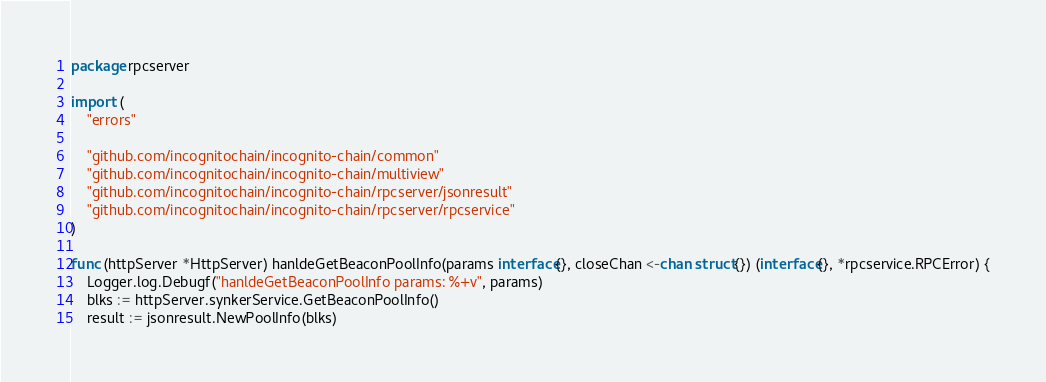<code> <loc_0><loc_0><loc_500><loc_500><_Go_>package rpcserver

import (
	"errors"

	"github.com/incognitochain/incognito-chain/common"
	"github.com/incognitochain/incognito-chain/multiview"
	"github.com/incognitochain/incognito-chain/rpcserver/jsonresult"
	"github.com/incognitochain/incognito-chain/rpcserver/rpcservice"
)

func (httpServer *HttpServer) hanldeGetBeaconPoolInfo(params interface{}, closeChan <-chan struct{}) (interface{}, *rpcservice.RPCError) {
	Logger.log.Debugf("hanldeGetBeaconPoolInfo params: %+v", params)
	blks := httpServer.synkerService.GetBeaconPoolInfo()
	result := jsonresult.NewPoolInfo(blks)</code> 